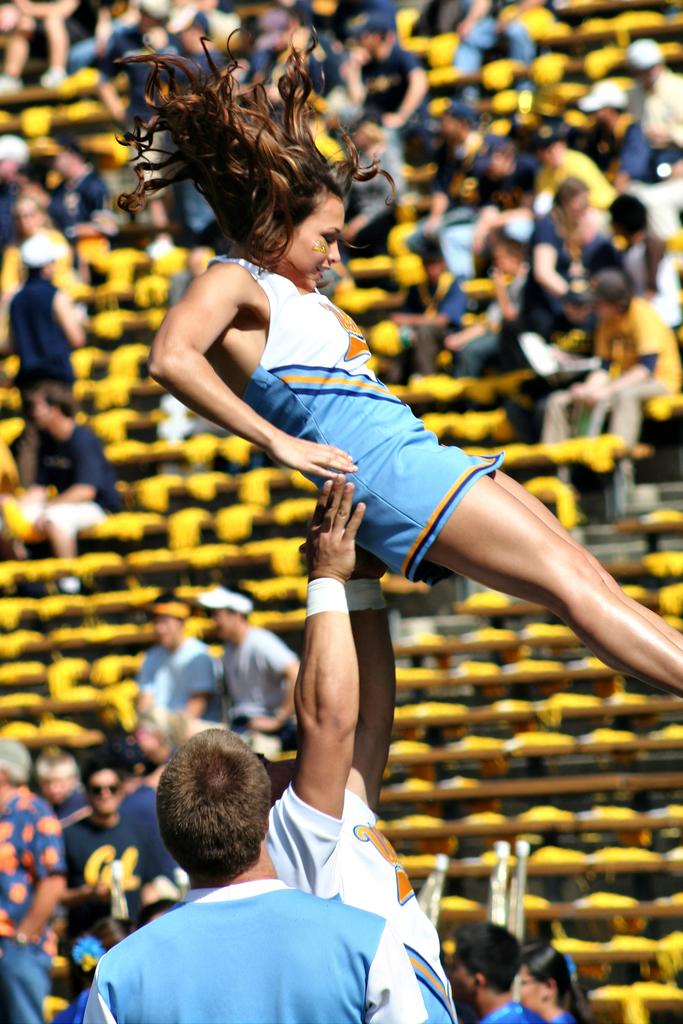How many people are in the image? There are people in the image, but the exact number is not specified. What action is being performed by the man in the image? A man is lifting a woman in the air with his hands. What can be observed about the background of the image? The background of the image is blurred. What type of furniture is present in the image? There are benches in the image. What type of coal is being used to create trouble in the image? There is no coal or trouble depicted in the image; it features people with a man lifting a woman in the air, and the background is blurred. 